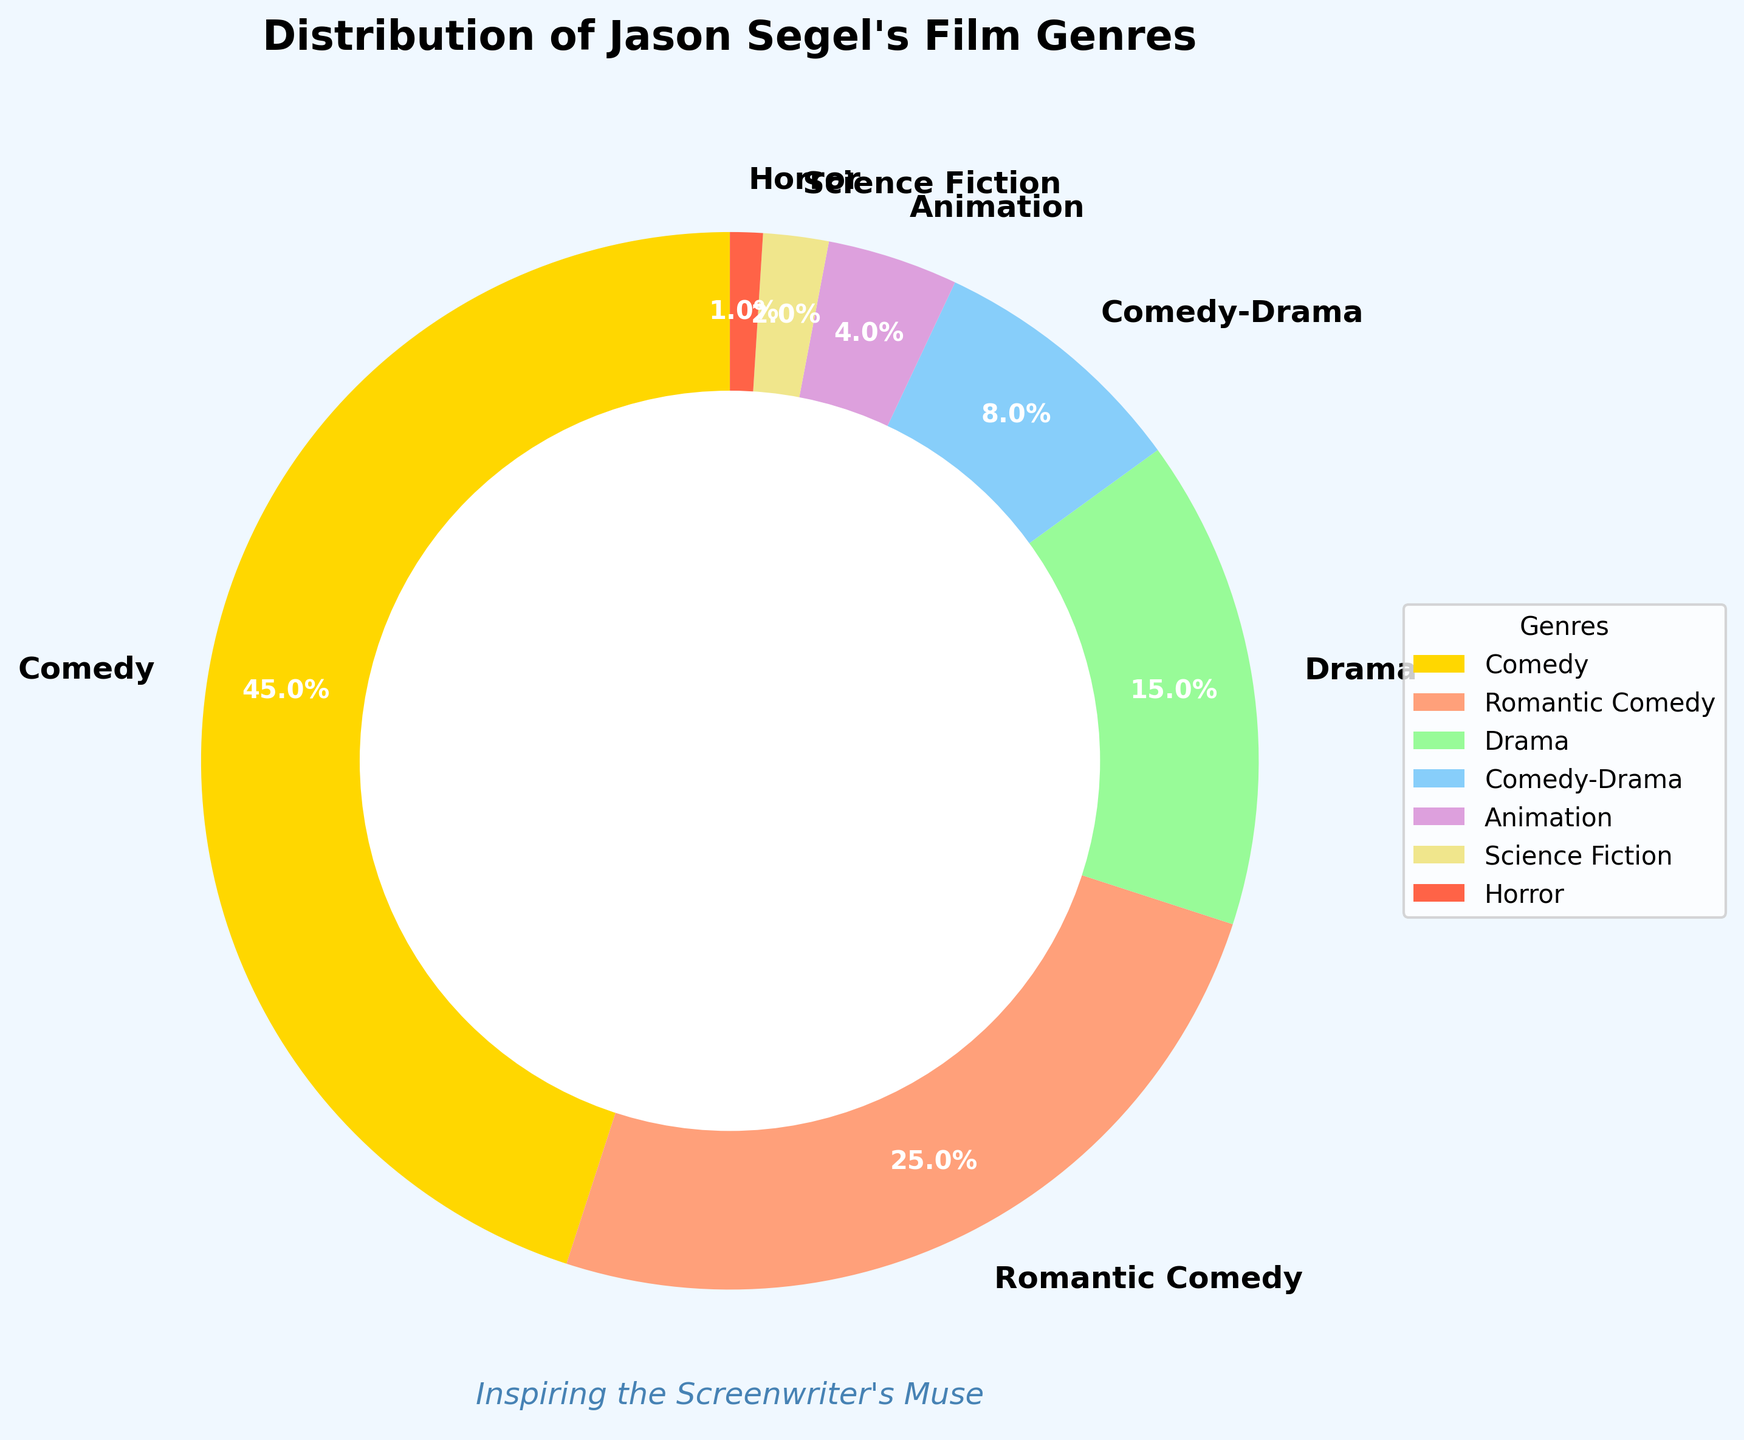What is the percentage of Jason Segel's movies that belong to the genres "Drama" and "Comedy-Drama" combined? First, identify the percentages of both "Drama" (15%) and "Comedy-Drama" (8%). Then, sum these two percentages: 15% + 8% = 23%.
Answer: 23% Which genre has the smallest representation in Jason Segel's filmography, and what percentage does it represent? By looking at the pie chart, the genre with the smallest slice is "Horror", which represents 1%.
Answer: Horror, 1% Which has a higher percentage of Jason Segel's movies: "Romantic Comedy" or "Science Fiction"? Refer to the chart to compare the percentages: "Romantic Comedy" (25%) and "Science Fiction" (2%). "Romantic Comedy" has a higher percentage.
Answer: Romantic Comedy What are the three most significant genres in Jason Segel's film career in order? Observe the pie chart to determine the sizes of the slices. The largest three are "Comedy" (45%), "Romantic Comedy" (25%), and "Drama" (15%).
Answer: Comedy, Romantic Comedy, Drama By how much does the percentage of "Comedy" movies exceed the combined percentage of "Animation" and "Science Fiction"? First, identify the percentage for "Comedy" (45%), "Animation" (4%), and "Science Fiction" (2%). Then, sum "Animation" and "Science Fiction": 4% + 2% = 6%. Finally, compute the difference: 45% - 6% = 39%.
Answer: 39% What is the total percentage of genres that are not "Comedy" or "Romantic Comedy"? First, identify and sum the percentages of all genres except "Comedy" (45%) and "Romantic Comedy" (25%). The remaining genres add up as follows: Drama (15%) + Comedy-Drama (8%) + Animation (4%) + Science Fiction (2%) + Horror (1%) = 30%.
Answer: 30% Which color is associated with the "Animation" genre in the pie chart? By observing the different colors in the pie chart and identifying the corresponding segment for "Animation", it is noted as a light purple shade.
Answer: Light purple How many genres are represented by more than 10% of Jason Segel's movies? Check the pie chart for segments whose sizes exceed 10%. The genres are "Comedy" (45%), "Romantic Comedy" (25%), and "Drama" (15%), making a total of three genres.
Answer: Three 